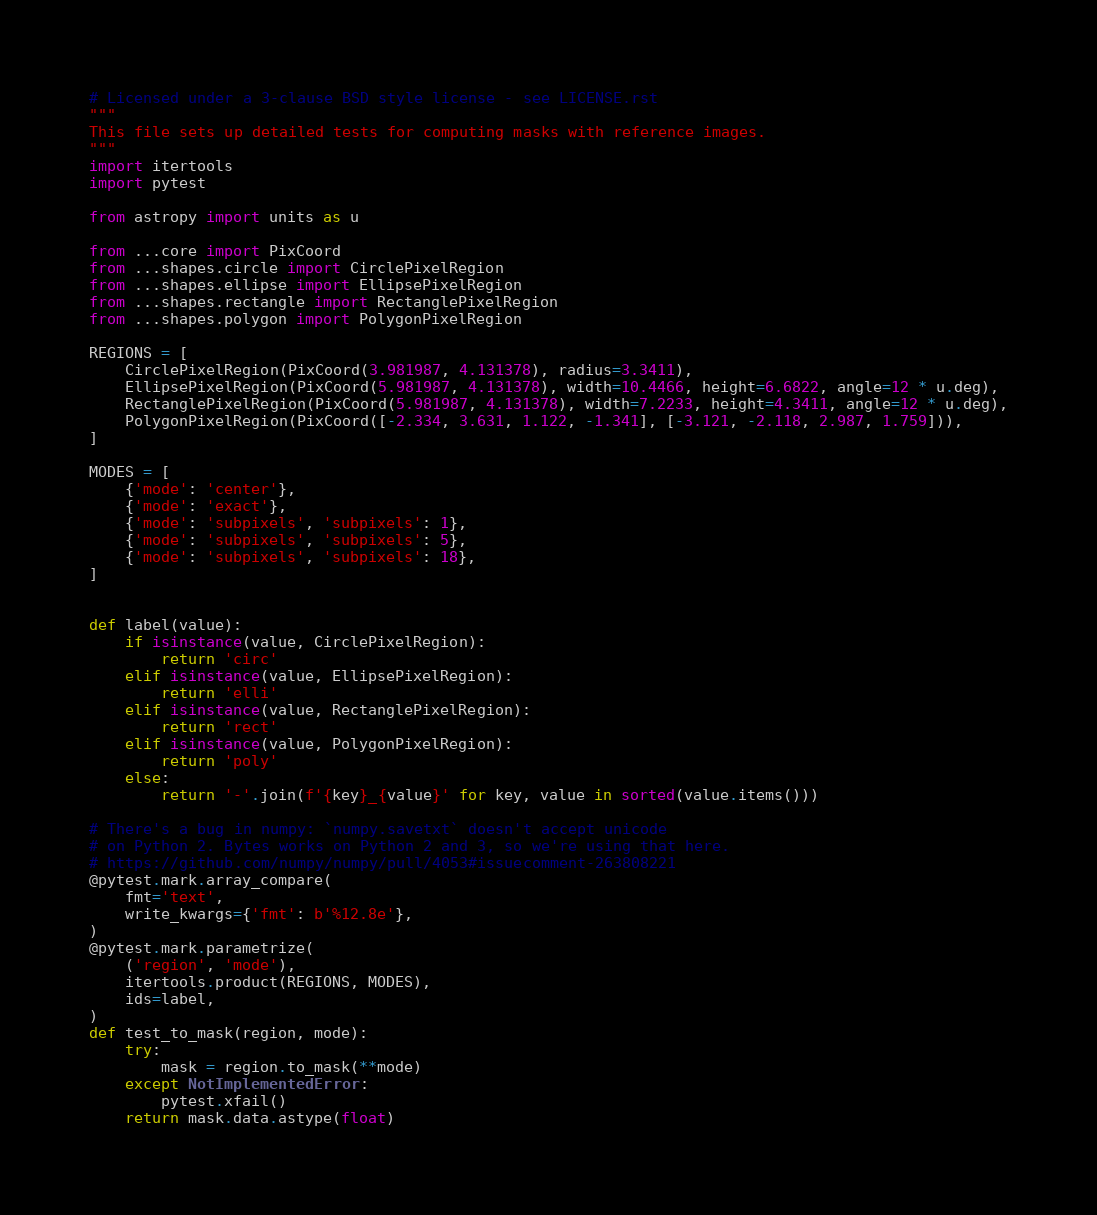<code> <loc_0><loc_0><loc_500><loc_500><_Python_># Licensed under a 3-clause BSD style license - see LICENSE.rst
"""
This file sets up detailed tests for computing masks with reference images.
"""
import itertools
import pytest

from astropy import units as u

from ...core import PixCoord
from ...shapes.circle import CirclePixelRegion
from ...shapes.ellipse import EllipsePixelRegion
from ...shapes.rectangle import RectanglePixelRegion
from ...shapes.polygon import PolygonPixelRegion

REGIONS = [
    CirclePixelRegion(PixCoord(3.981987, 4.131378), radius=3.3411),
    EllipsePixelRegion(PixCoord(5.981987, 4.131378), width=10.4466, height=6.6822, angle=12 * u.deg),
    RectanglePixelRegion(PixCoord(5.981987, 4.131378), width=7.2233, height=4.3411, angle=12 * u.deg),
    PolygonPixelRegion(PixCoord([-2.334, 3.631, 1.122, -1.341], [-3.121, -2.118, 2.987, 1.759])),
]

MODES = [
    {'mode': 'center'},
    {'mode': 'exact'},
    {'mode': 'subpixels', 'subpixels': 1},
    {'mode': 'subpixels', 'subpixels': 5},
    {'mode': 'subpixels', 'subpixels': 18},
]


def label(value):
    if isinstance(value, CirclePixelRegion):
        return 'circ'
    elif isinstance(value, EllipsePixelRegion):
        return 'elli'
    elif isinstance(value, RectanglePixelRegion):
        return 'rect'
    elif isinstance(value, PolygonPixelRegion):
        return 'poly'
    else:
        return '-'.join(f'{key}_{value}' for key, value in sorted(value.items()))

# There's a bug in numpy: `numpy.savetxt` doesn't accept unicode
# on Python 2. Bytes works on Python 2 and 3, so we're using that here.
# https://github.com/numpy/numpy/pull/4053#issuecomment-263808221
@pytest.mark.array_compare(
    fmt='text',
    write_kwargs={'fmt': b'%12.8e'},
)
@pytest.mark.parametrize(
    ('region', 'mode'),
    itertools.product(REGIONS, MODES),
    ids=label,
)
def test_to_mask(region, mode):
    try:
        mask = region.to_mask(**mode)
    except NotImplementedError:
        pytest.xfail()
    return mask.data.astype(float)
</code> 